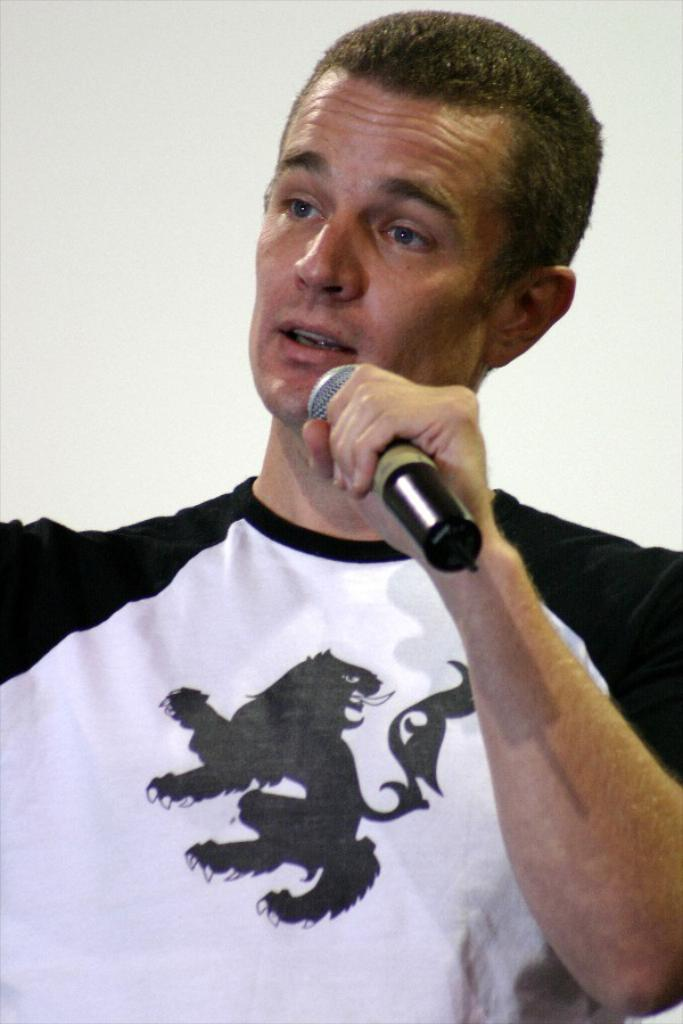Who or what is the main subject in the image? There is a person in the center of the image. What is the person holding in the image? The person is holding a microphone. What can be seen behind the person in the image? There is a wall in the background of the image. Can you see any goldfish swimming in the image? There are no goldfish present in the image. 